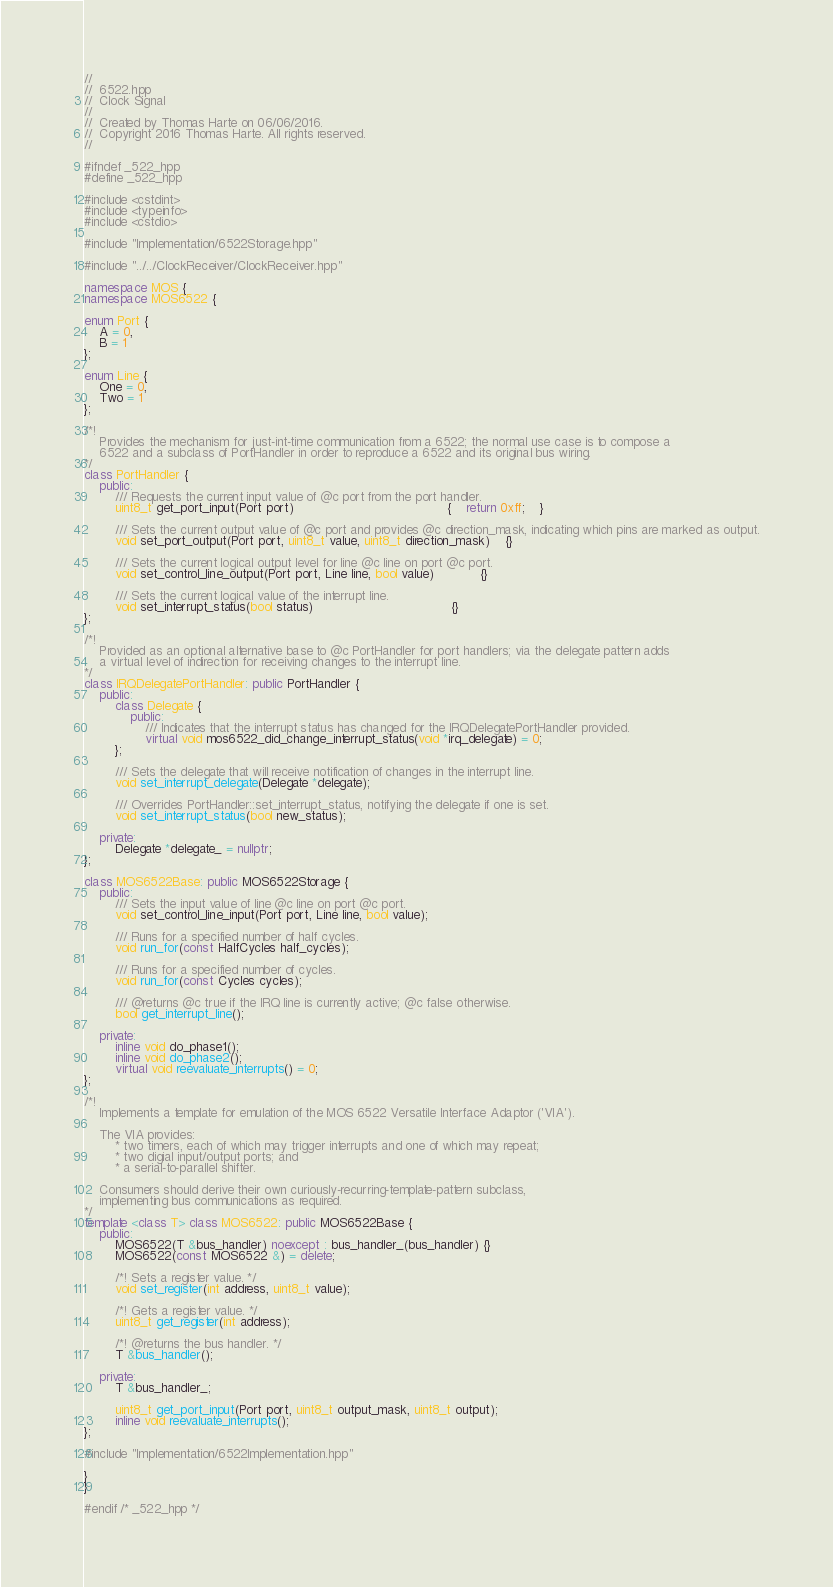<code> <loc_0><loc_0><loc_500><loc_500><_C++_>//
//  6522.hpp
//  Clock Signal
//
//  Created by Thomas Harte on 06/06/2016.
//  Copyright 2016 Thomas Harte. All rights reserved.
//

#ifndef _522_hpp
#define _522_hpp

#include <cstdint>
#include <typeinfo>
#include <cstdio>

#include "Implementation/6522Storage.hpp"

#include "../../ClockReceiver/ClockReceiver.hpp"

namespace MOS {
namespace MOS6522 {

enum Port {
	A = 0,
	B = 1
};

enum Line {
	One = 0,
	Two = 1
};

/*!
	Provides the mechanism for just-int-time communication from a 6522; the normal use case is to compose a
	6522 and a subclass of PortHandler in order to reproduce a 6522 and its original bus wiring.
*/
class PortHandler {
	public:
		/// Requests the current input value of @c port from the port handler.
		uint8_t get_port_input(Port port)										{	return 0xff;	}

		/// Sets the current output value of @c port and provides @c direction_mask, indicating which pins are marked as output.
		void set_port_output(Port port, uint8_t value, uint8_t direction_mask)	{}

		/// Sets the current logical output level for line @c line on port @c port.
		void set_control_line_output(Port port, Line line, bool value)			{}

		/// Sets the current logical value of the interrupt line.
		void set_interrupt_status(bool status)									{}
};

/*!
	Provided as an optional alternative base to @c PortHandler for port handlers; via the delegate pattern adds
	a virtual level of indirection for receiving changes to the interrupt line.
*/
class IRQDelegatePortHandler: public PortHandler {
	public:
		class Delegate {
			public:
				/// Indicates that the interrupt status has changed for the IRQDelegatePortHandler provided.
				virtual void mos6522_did_change_interrupt_status(void *irq_delegate) = 0;
		};

		/// Sets the delegate that will receive notification of changes in the interrupt line.
		void set_interrupt_delegate(Delegate *delegate);

		/// Overrides PortHandler::set_interrupt_status, notifying the delegate if one is set.
		void set_interrupt_status(bool new_status);

	private:
		Delegate *delegate_ = nullptr;
};

class MOS6522Base: public MOS6522Storage {
	public:
		/// Sets the input value of line @c line on port @c port.
		void set_control_line_input(Port port, Line line, bool value);

		/// Runs for a specified number of half cycles.
		void run_for(const HalfCycles half_cycles);

		/// Runs for a specified number of cycles.
		void run_for(const Cycles cycles);

		/// @returns @c true if the IRQ line is currently active; @c false otherwise.
		bool get_interrupt_line();

	private:
		inline void do_phase1();
		inline void do_phase2();
		virtual void reevaluate_interrupts() = 0;
};

/*!
	Implements a template for emulation of the MOS 6522 Versatile Interface Adaptor ('VIA').

	The VIA provides:
		* two timers, each of which may trigger interrupts and one of which may repeat;
		* two digial input/output ports; and
		* a serial-to-parallel shifter.

	Consumers should derive their own curiously-recurring-template-pattern subclass,
	implementing bus communications as required.
*/
template <class T> class MOS6522: public MOS6522Base {
	public:
		MOS6522(T &bus_handler) noexcept : bus_handler_(bus_handler) {}
		MOS6522(const MOS6522 &) = delete;

		/*! Sets a register value. */
		void set_register(int address, uint8_t value);

		/*! Gets a register value. */
		uint8_t get_register(int address);

		/*! @returns the bus handler. */
		T &bus_handler();

	private:
		T &bus_handler_;

		uint8_t get_port_input(Port port, uint8_t output_mask, uint8_t output);
		inline void reevaluate_interrupts();
};

#include "Implementation/6522Implementation.hpp"

}
}

#endif /* _522_hpp */
</code> 